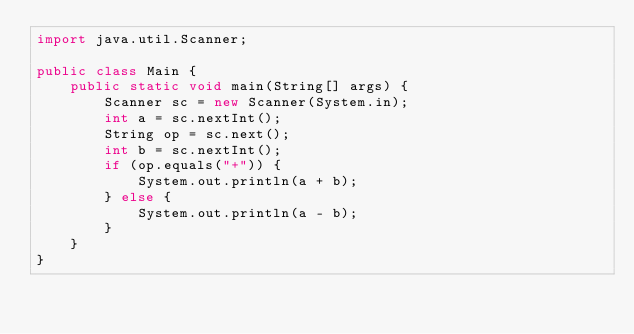Convert code to text. <code><loc_0><loc_0><loc_500><loc_500><_Java_>import java.util.Scanner;

public class Main {
	public static void main(String[] args) {
		Scanner sc = new Scanner(System.in);
		int a = sc.nextInt();
		String op = sc.next();
		int b = sc.nextInt();
		if (op.equals("+")) {
			System.out.println(a + b);
		} else {
			System.out.println(a - b);
		}
	}
}</code> 